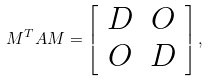<formula> <loc_0><loc_0><loc_500><loc_500>M ^ { T } A M = \left [ \begin{array} { c c } D & O \\ O & D \end{array} \right ] ,</formula> 